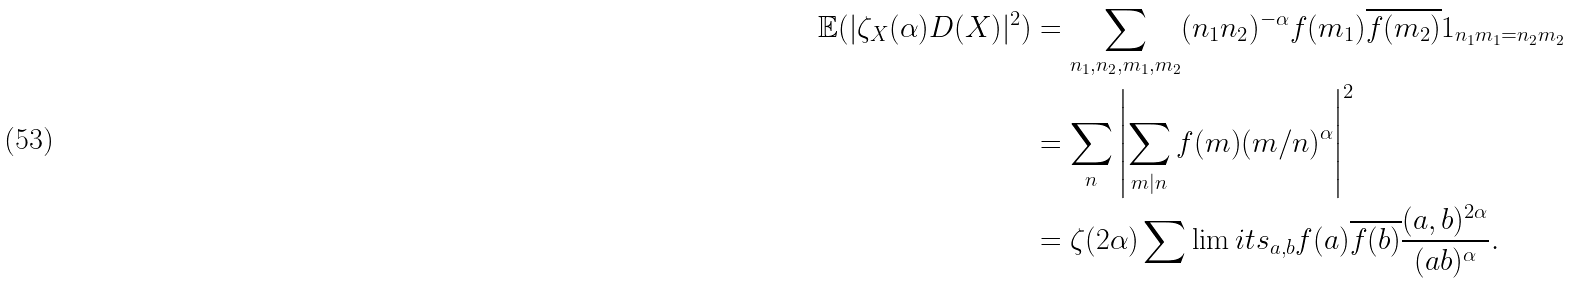<formula> <loc_0><loc_0><loc_500><loc_500>\mathbb { E } ( | \zeta _ { X } ( \alpha ) D ( X ) | ^ { 2 } ) & = \sum _ { n _ { 1 } , n _ { 2 } , m _ { 1 } , m _ { 2 } } ( n _ { 1 } n _ { 2 } ) ^ { - \alpha } f ( m _ { 1 } ) \overline { f ( m _ { 2 } ) } 1 _ { n _ { 1 } m _ { 1 } = n _ { 2 } m _ { 2 } } \\ & = \sum _ { n } \left | \sum _ { m | n } f ( m ) ( m / n ) ^ { \alpha } \right | ^ { 2 } \\ & = \zeta ( 2 \alpha ) \sum \lim i t s _ { a , b } f ( a ) \overline { f ( b ) } \frac { ( a , b ) ^ { 2 \alpha } } { ( a b ) ^ { \alpha } } .</formula> 